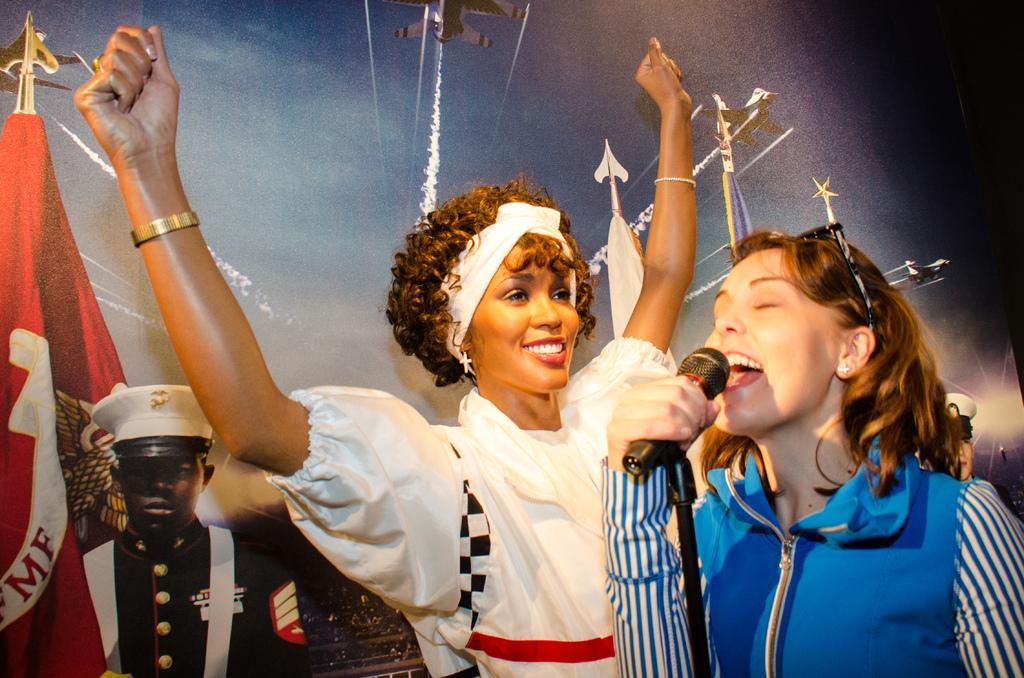Could you give a brief overview of what you see in this image? In this image there is a girl on the right side who is singing with the mic. In the background there is another woman who is standing by raising her hands. On the left side there is a man standing beside the flag. In the background there is banner. 